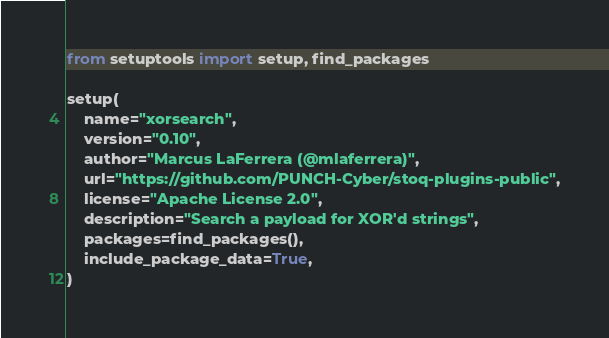<code> <loc_0><loc_0><loc_500><loc_500><_Python_>from setuptools import setup, find_packages

setup(
    name="xorsearch",
    version="0.10",
    author="Marcus LaFerrera (@mlaferrera)",
    url="https://github.com/PUNCH-Cyber/stoq-plugins-public",
    license="Apache License 2.0",
    description="Search a payload for XOR'd strings",
    packages=find_packages(),
    include_package_data=True,
)
</code> 